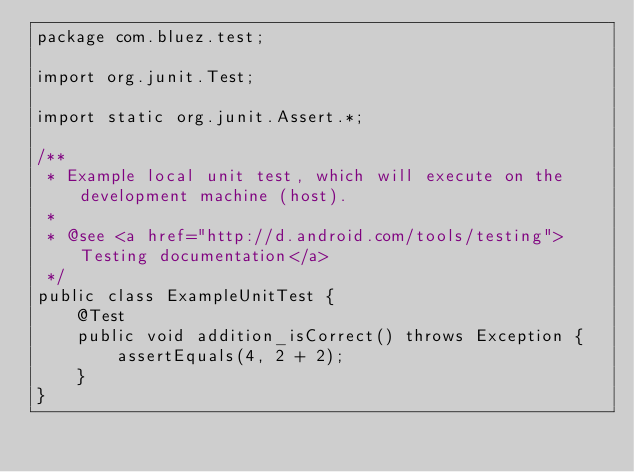Convert code to text. <code><loc_0><loc_0><loc_500><loc_500><_Java_>package com.bluez.test;

import org.junit.Test;

import static org.junit.Assert.*;

/**
 * Example local unit test, which will execute on the development machine (host).
 *
 * @see <a href="http://d.android.com/tools/testing">Testing documentation</a>
 */
public class ExampleUnitTest {
    @Test
    public void addition_isCorrect() throws Exception {
        assertEquals(4, 2 + 2);
    }
}</code> 